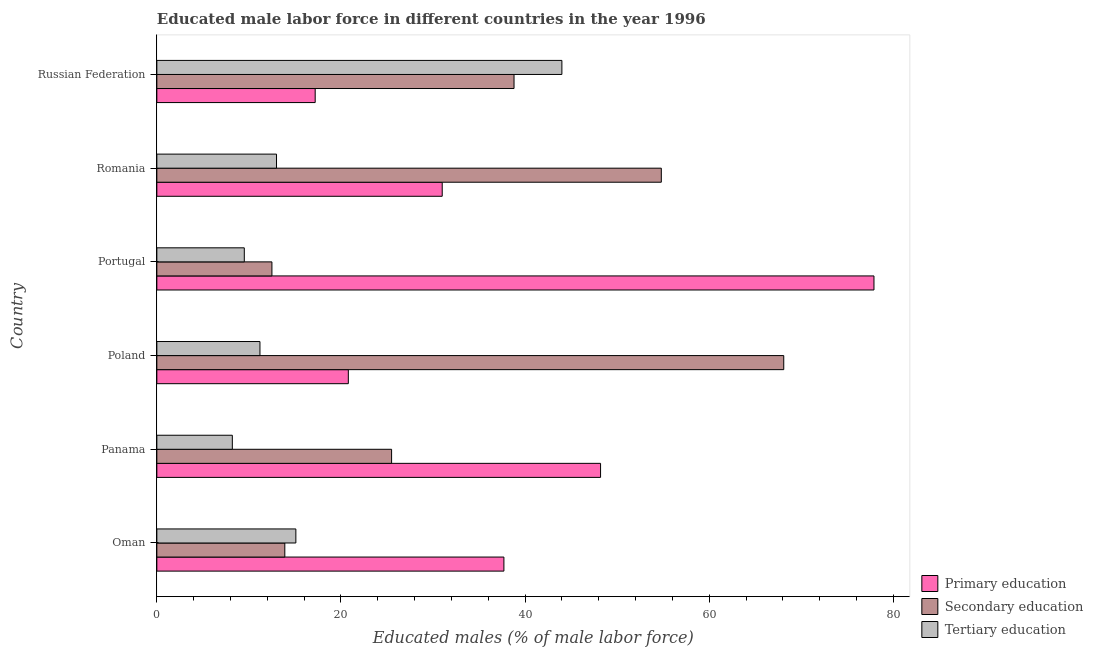Are the number of bars per tick equal to the number of legend labels?
Give a very brief answer. Yes. What is the label of the 6th group of bars from the top?
Your response must be concise. Oman. In how many cases, is the number of bars for a given country not equal to the number of legend labels?
Keep it short and to the point. 0. What is the percentage of male labor force who received tertiary education in Oman?
Offer a terse response. 15.1. Across all countries, what is the maximum percentage of male labor force who received tertiary education?
Ensure brevity in your answer.  44. In which country was the percentage of male labor force who received primary education minimum?
Ensure brevity in your answer.  Russian Federation. What is the total percentage of male labor force who received tertiary education in the graph?
Provide a succinct answer. 101. What is the difference between the percentage of male labor force who received secondary education in Poland and that in Russian Federation?
Make the answer very short. 29.3. What is the difference between the percentage of male labor force who received primary education in Panama and the percentage of male labor force who received tertiary education in Russian Federation?
Your answer should be compact. 4.2. What is the average percentage of male labor force who received tertiary education per country?
Your answer should be compact. 16.83. What is the ratio of the percentage of male labor force who received primary education in Oman to that in Russian Federation?
Make the answer very short. 2.19. Is the percentage of male labor force who received secondary education in Poland less than that in Russian Federation?
Keep it short and to the point. No. What is the difference between the highest and the second highest percentage of male labor force who received tertiary education?
Make the answer very short. 28.9. What is the difference between the highest and the lowest percentage of male labor force who received tertiary education?
Your response must be concise. 35.8. Is the sum of the percentage of male labor force who received secondary education in Oman and Poland greater than the maximum percentage of male labor force who received tertiary education across all countries?
Ensure brevity in your answer.  Yes. What does the 3rd bar from the top in Poland represents?
Give a very brief answer. Primary education. What does the 3rd bar from the bottom in Portugal represents?
Offer a very short reply. Tertiary education. Are all the bars in the graph horizontal?
Provide a short and direct response. Yes. How many countries are there in the graph?
Provide a short and direct response. 6. What is the difference between two consecutive major ticks on the X-axis?
Give a very brief answer. 20. Are the values on the major ticks of X-axis written in scientific E-notation?
Offer a very short reply. No. Does the graph contain grids?
Offer a terse response. No. How many legend labels are there?
Your response must be concise. 3. How are the legend labels stacked?
Give a very brief answer. Vertical. What is the title of the graph?
Provide a short and direct response. Educated male labor force in different countries in the year 1996. Does "Food" appear as one of the legend labels in the graph?
Your answer should be very brief. No. What is the label or title of the X-axis?
Offer a very short reply. Educated males (% of male labor force). What is the Educated males (% of male labor force) of Primary education in Oman?
Offer a terse response. 37.7. What is the Educated males (% of male labor force) of Secondary education in Oman?
Offer a terse response. 13.9. What is the Educated males (% of male labor force) of Tertiary education in Oman?
Your response must be concise. 15.1. What is the Educated males (% of male labor force) in Primary education in Panama?
Give a very brief answer. 48.2. What is the Educated males (% of male labor force) in Secondary education in Panama?
Ensure brevity in your answer.  25.5. What is the Educated males (% of male labor force) of Tertiary education in Panama?
Keep it short and to the point. 8.2. What is the Educated males (% of male labor force) of Primary education in Poland?
Your answer should be compact. 20.8. What is the Educated males (% of male labor force) of Secondary education in Poland?
Keep it short and to the point. 68.1. What is the Educated males (% of male labor force) of Tertiary education in Poland?
Your response must be concise. 11.2. What is the Educated males (% of male labor force) of Primary education in Portugal?
Keep it short and to the point. 77.9. What is the Educated males (% of male labor force) of Tertiary education in Portugal?
Give a very brief answer. 9.5. What is the Educated males (% of male labor force) in Secondary education in Romania?
Your answer should be compact. 54.8. What is the Educated males (% of male labor force) of Primary education in Russian Federation?
Provide a succinct answer. 17.2. What is the Educated males (% of male labor force) of Secondary education in Russian Federation?
Offer a very short reply. 38.8. What is the Educated males (% of male labor force) of Tertiary education in Russian Federation?
Give a very brief answer. 44. Across all countries, what is the maximum Educated males (% of male labor force) of Primary education?
Give a very brief answer. 77.9. Across all countries, what is the maximum Educated males (% of male labor force) of Secondary education?
Provide a succinct answer. 68.1. Across all countries, what is the minimum Educated males (% of male labor force) of Primary education?
Offer a terse response. 17.2. Across all countries, what is the minimum Educated males (% of male labor force) in Tertiary education?
Give a very brief answer. 8.2. What is the total Educated males (% of male labor force) of Primary education in the graph?
Offer a terse response. 232.8. What is the total Educated males (% of male labor force) of Secondary education in the graph?
Make the answer very short. 213.6. What is the total Educated males (% of male labor force) in Tertiary education in the graph?
Your answer should be compact. 101. What is the difference between the Educated males (% of male labor force) in Tertiary education in Oman and that in Panama?
Provide a short and direct response. 6.9. What is the difference between the Educated males (% of male labor force) in Secondary education in Oman and that in Poland?
Make the answer very short. -54.2. What is the difference between the Educated males (% of male labor force) in Primary education in Oman and that in Portugal?
Give a very brief answer. -40.2. What is the difference between the Educated males (% of male labor force) of Secondary education in Oman and that in Portugal?
Your answer should be very brief. 1.4. What is the difference between the Educated males (% of male labor force) of Secondary education in Oman and that in Romania?
Keep it short and to the point. -40.9. What is the difference between the Educated males (% of male labor force) in Primary education in Oman and that in Russian Federation?
Provide a succinct answer. 20.5. What is the difference between the Educated males (% of male labor force) of Secondary education in Oman and that in Russian Federation?
Your answer should be very brief. -24.9. What is the difference between the Educated males (% of male labor force) in Tertiary education in Oman and that in Russian Federation?
Your answer should be compact. -28.9. What is the difference between the Educated males (% of male labor force) of Primary education in Panama and that in Poland?
Offer a very short reply. 27.4. What is the difference between the Educated males (% of male labor force) in Secondary education in Panama and that in Poland?
Keep it short and to the point. -42.6. What is the difference between the Educated males (% of male labor force) in Primary education in Panama and that in Portugal?
Provide a short and direct response. -29.7. What is the difference between the Educated males (% of male labor force) of Primary education in Panama and that in Romania?
Ensure brevity in your answer.  17.2. What is the difference between the Educated males (% of male labor force) in Secondary education in Panama and that in Romania?
Your response must be concise. -29.3. What is the difference between the Educated males (% of male labor force) in Tertiary education in Panama and that in Romania?
Your response must be concise. -4.8. What is the difference between the Educated males (% of male labor force) in Secondary education in Panama and that in Russian Federation?
Your answer should be compact. -13.3. What is the difference between the Educated males (% of male labor force) in Tertiary education in Panama and that in Russian Federation?
Offer a terse response. -35.8. What is the difference between the Educated males (% of male labor force) in Primary education in Poland and that in Portugal?
Provide a short and direct response. -57.1. What is the difference between the Educated males (% of male labor force) in Secondary education in Poland and that in Portugal?
Offer a very short reply. 55.6. What is the difference between the Educated males (% of male labor force) of Secondary education in Poland and that in Romania?
Provide a short and direct response. 13.3. What is the difference between the Educated males (% of male labor force) in Tertiary education in Poland and that in Romania?
Provide a succinct answer. -1.8. What is the difference between the Educated males (% of male labor force) of Primary education in Poland and that in Russian Federation?
Keep it short and to the point. 3.6. What is the difference between the Educated males (% of male labor force) in Secondary education in Poland and that in Russian Federation?
Offer a terse response. 29.3. What is the difference between the Educated males (% of male labor force) of Tertiary education in Poland and that in Russian Federation?
Make the answer very short. -32.8. What is the difference between the Educated males (% of male labor force) in Primary education in Portugal and that in Romania?
Your answer should be compact. 46.9. What is the difference between the Educated males (% of male labor force) of Secondary education in Portugal and that in Romania?
Provide a succinct answer. -42.3. What is the difference between the Educated males (% of male labor force) of Tertiary education in Portugal and that in Romania?
Provide a succinct answer. -3.5. What is the difference between the Educated males (% of male labor force) of Primary education in Portugal and that in Russian Federation?
Give a very brief answer. 60.7. What is the difference between the Educated males (% of male labor force) in Secondary education in Portugal and that in Russian Federation?
Ensure brevity in your answer.  -26.3. What is the difference between the Educated males (% of male labor force) of Tertiary education in Portugal and that in Russian Federation?
Your answer should be very brief. -34.5. What is the difference between the Educated males (% of male labor force) in Primary education in Romania and that in Russian Federation?
Offer a terse response. 13.8. What is the difference between the Educated males (% of male labor force) in Tertiary education in Romania and that in Russian Federation?
Keep it short and to the point. -31. What is the difference between the Educated males (% of male labor force) in Primary education in Oman and the Educated males (% of male labor force) in Tertiary education in Panama?
Offer a very short reply. 29.5. What is the difference between the Educated males (% of male labor force) of Secondary education in Oman and the Educated males (% of male labor force) of Tertiary education in Panama?
Offer a terse response. 5.7. What is the difference between the Educated males (% of male labor force) in Primary education in Oman and the Educated males (% of male labor force) in Secondary education in Poland?
Ensure brevity in your answer.  -30.4. What is the difference between the Educated males (% of male labor force) in Secondary education in Oman and the Educated males (% of male labor force) in Tertiary education in Poland?
Provide a short and direct response. 2.7. What is the difference between the Educated males (% of male labor force) of Primary education in Oman and the Educated males (% of male labor force) of Secondary education in Portugal?
Ensure brevity in your answer.  25.2. What is the difference between the Educated males (% of male labor force) in Primary education in Oman and the Educated males (% of male labor force) in Tertiary education in Portugal?
Give a very brief answer. 28.2. What is the difference between the Educated males (% of male labor force) of Primary education in Oman and the Educated males (% of male labor force) of Secondary education in Romania?
Give a very brief answer. -17.1. What is the difference between the Educated males (% of male labor force) in Primary education in Oman and the Educated males (% of male labor force) in Tertiary education in Romania?
Your answer should be very brief. 24.7. What is the difference between the Educated males (% of male labor force) of Secondary education in Oman and the Educated males (% of male labor force) of Tertiary education in Romania?
Provide a succinct answer. 0.9. What is the difference between the Educated males (% of male labor force) of Primary education in Oman and the Educated males (% of male labor force) of Secondary education in Russian Federation?
Provide a succinct answer. -1.1. What is the difference between the Educated males (% of male labor force) in Primary education in Oman and the Educated males (% of male labor force) in Tertiary education in Russian Federation?
Make the answer very short. -6.3. What is the difference between the Educated males (% of male labor force) of Secondary education in Oman and the Educated males (% of male labor force) of Tertiary education in Russian Federation?
Ensure brevity in your answer.  -30.1. What is the difference between the Educated males (% of male labor force) in Primary education in Panama and the Educated males (% of male labor force) in Secondary education in Poland?
Your answer should be very brief. -19.9. What is the difference between the Educated males (% of male labor force) in Primary education in Panama and the Educated males (% of male labor force) in Tertiary education in Poland?
Give a very brief answer. 37. What is the difference between the Educated males (% of male labor force) of Secondary education in Panama and the Educated males (% of male labor force) of Tertiary education in Poland?
Provide a short and direct response. 14.3. What is the difference between the Educated males (% of male labor force) of Primary education in Panama and the Educated males (% of male labor force) of Secondary education in Portugal?
Give a very brief answer. 35.7. What is the difference between the Educated males (% of male labor force) of Primary education in Panama and the Educated males (% of male labor force) of Tertiary education in Portugal?
Your answer should be compact. 38.7. What is the difference between the Educated males (% of male labor force) in Secondary education in Panama and the Educated males (% of male labor force) in Tertiary education in Portugal?
Make the answer very short. 16. What is the difference between the Educated males (% of male labor force) in Primary education in Panama and the Educated males (% of male labor force) in Tertiary education in Romania?
Your answer should be very brief. 35.2. What is the difference between the Educated males (% of male labor force) of Secondary education in Panama and the Educated males (% of male labor force) of Tertiary education in Romania?
Offer a very short reply. 12.5. What is the difference between the Educated males (% of male labor force) in Primary education in Panama and the Educated males (% of male labor force) in Secondary education in Russian Federation?
Offer a terse response. 9.4. What is the difference between the Educated males (% of male labor force) of Primary education in Panama and the Educated males (% of male labor force) of Tertiary education in Russian Federation?
Give a very brief answer. 4.2. What is the difference between the Educated males (% of male labor force) in Secondary education in Panama and the Educated males (% of male labor force) in Tertiary education in Russian Federation?
Make the answer very short. -18.5. What is the difference between the Educated males (% of male labor force) in Secondary education in Poland and the Educated males (% of male labor force) in Tertiary education in Portugal?
Ensure brevity in your answer.  58.6. What is the difference between the Educated males (% of male labor force) in Primary education in Poland and the Educated males (% of male labor force) in Secondary education in Romania?
Offer a terse response. -34. What is the difference between the Educated males (% of male labor force) of Primary education in Poland and the Educated males (% of male labor force) of Tertiary education in Romania?
Provide a succinct answer. 7.8. What is the difference between the Educated males (% of male labor force) of Secondary education in Poland and the Educated males (% of male labor force) of Tertiary education in Romania?
Your answer should be compact. 55.1. What is the difference between the Educated males (% of male labor force) of Primary education in Poland and the Educated males (% of male labor force) of Tertiary education in Russian Federation?
Keep it short and to the point. -23.2. What is the difference between the Educated males (% of male labor force) in Secondary education in Poland and the Educated males (% of male labor force) in Tertiary education in Russian Federation?
Make the answer very short. 24.1. What is the difference between the Educated males (% of male labor force) of Primary education in Portugal and the Educated males (% of male labor force) of Secondary education in Romania?
Offer a terse response. 23.1. What is the difference between the Educated males (% of male labor force) of Primary education in Portugal and the Educated males (% of male labor force) of Tertiary education in Romania?
Your answer should be very brief. 64.9. What is the difference between the Educated males (% of male labor force) in Secondary education in Portugal and the Educated males (% of male labor force) in Tertiary education in Romania?
Your response must be concise. -0.5. What is the difference between the Educated males (% of male labor force) of Primary education in Portugal and the Educated males (% of male labor force) of Secondary education in Russian Federation?
Make the answer very short. 39.1. What is the difference between the Educated males (% of male labor force) of Primary education in Portugal and the Educated males (% of male labor force) of Tertiary education in Russian Federation?
Make the answer very short. 33.9. What is the difference between the Educated males (% of male labor force) of Secondary education in Portugal and the Educated males (% of male labor force) of Tertiary education in Russian Federation?
Your response must be concise. -31.5. What is the difference between the Educated males (% of male labor force) of Primary education in Romania and the Educated males (% of male labor force) of Secondary education in Russian Federation?
Provide a short and direct response. -7.8. What is the average Educated males (% of male labor force) in Primary education per country?
Make the answer very short. 38.8. What is the average Educated males (% of male labor force) in Secondary education per country?
Make the answer very short. 35.6. What is the average Educated males (% of male labor force) in Tertiary education per country?
Offer a very short reply. 16.83. What is the difference between the Educated males (% of male labor force) in Primary education and Educated males (% of male labor force) in Secondary education in Oman?
Your answer should be very brief. 23.8. What is the difference between the Educated males (% of male labor force) of Primary education and Educated males (% of male labor force) of Tertiary education in Oman?
Provide a short and direct response. 22.6. What is the difference between the Educated males (% of male labor force) in Secondary education and Educated males (% of male labor force) in Tertiary education in Oman?
Ensure brevity in your answer.  -1.2. What is the difference between the Educated males (% of male labor force) of Primary education and Educated males (% of male labor force) of Secondary education in Panama?
Offer a very short reply. 22.7. What is the difference between the Educated males (% of male labor force) in Primary education and Educated males (% of male labor force) in Secondary education in Poland?
Provide a succinct answer. -47.3. What is the difference between the Educated males (% of male labor force) of Primary education and Educated males (% of male labor force) of Tertiary education in Poland?
Offer a very short reply. 9.6. What is the difference between the Educated males (% of male labor force) of Secondary education and Educated males (% of male labor force) of Tertiary education in Poland?
Ensure brevity in your answer.  56.9. What is the difference between the Educated males (% of male labor force) in Primary education and Educated males (% of male labor force) in Secondary education in Portugal?
Provide a succinct answer. 65.4. What is the difference between the Educated males (% of male labor force) of Primary education and Educated males (% of male labor force) of Tertiary education in Portugal?
Your answer should be compact. 68.4. What is the difference between the Educated males (% of male labor force) of Primary education and Educated males (% of male labor force) of Secondary education in Romania?
Make the answer very short. -23.8. What is the difference between the Educated males (% of male labor force) of Secondary education and Educated males (% of male labor force) of Tertiary education in Romania?
Your answer should be compact. 41.8. What is the difference between the Educated males (% of male labor force) of Primary education and Educated males (% of male labor force) of Secondary education in Russian Federation?
Offer a very short reply. -21.6. What is the difference between the Educated males (% of male labor force) of Primary education and Educated males (% of male labor force) of Tertiary education in Russian Federation?
Offer a very short reply. -26.8. What is the difference between the Educated males (% of male labor force) in Secondary education and Educated males (% of male labor force) in Tertiary education in Russian Federation?
Provide a succinct answer. -5.2. What is the ratio of the Educated males (% of male labor force) of Primary education in Oman to that in Panama?
Offer a very short reply. 0.78. What is the ratio of the Educated males (% of male labor force) in Secondary education in Oman to that in Panama?
Provide a succinct answer. 0.55. What is the ratio of the Educated males (% of male labor force) of Tertiary education in Oman to that in Panama?
Your answer should be very brief. 1.84. What is the ratio of the Educated males (% of male labor force) of Primary education in Oman to that in Poland?
Provide a succinct answer. 1.81. What is the ratio of the Educated males (% of male labor force) in Secondary education in Oman to that in Poland?
Keep it short and to the point. 0.2. What is the ratio of the Educated males (% of male labor force) of Tertiary education in Oman to that in Poland?
Provide a short and direct response. 1.35. What is the ratio of the Educated males (% of male labor force) in Primary education in Oman to that in Portugal?
Provide a succinct answer. 0.48. What is the ratio of the Educated males (% of male labor force) of Secondary education in Oman to that in Portugal?
Keep it short and to the point. 1.11. What is the ratio of the Educated males (% of male labor force) in Tertiary education in Oman to that in Portugal?
Provide a short and direct response. 1.59. What is the ratio of the Educated males (% of male labor force) of Primary education in Oman to that in Romania?
Keep it short and to the point. 1.22. What is the ratio of the Educated males (% of male labor force) in Secondary education in Oman to that in Romania?
Your answer should be compact. 0.25. What is the ratio of the Educated males (% of male labor force) in Tertiary education in Oman to that in Romania?
Keep it short and to the point. 1.16. What is the ratio of the Educated males (% of male labor force) in Primary education in Oman to that in Russian Federation?
Offer a terse response. 2.19. What is the ratio of the Educated males (% of male labor force) of Secondary education in Oman to that in Russian Federation?
Provide a succinct answer. 0.36. What is the ratio of the Educated males (% of male labor force) of Tertiary education in Oman to that in Russian Federation?
Your answer should be very brief. 0.34. What is the ratio of the Educated males (% of male labor force) in Primary education in Panama to that in Poland?
Offer a terse response. 2.32. What is the ratio of the Educated males (% of male labor force) in Secondary education in Panama to that in Poland?
Your answer should be very brief. 0.37. What is the ratio of the Educated males (% of male labor force) in Tertiary education in Panama to that in Poland?
Your answer should be very brief. 0.73. What is the ratio of the Educated males (% of male labor force) of Primary education in Panama to that in Portugal?
Provide a succinct answer. 0.62. What is the ratio of the Educated males (% of male labor force) of Secondary education in Panama to that in Portugal?
Provide a succinct answer. 2.04. What is the ratio of the Educated males (% of male labor force) of Tertiary education in Panama to that in Portugal?
Provide a succinct answer. 0.86. What is the ratio of the Educated males (% of male labor force) in Primary education in Panama to that in Romania?
Ensure brevity in your answer.  1.55. What is the ratio of the Educated males (% of male labor force) in Secondary education in Panama to that in Romania?
Ensure brevity in your answer.  0.47. What is the ratio of the Educated males (% of male labor force) of Tertiary education in Panama to that in Romania?
Ensure brevity in your answer.  0.63. What is the ratio of the Educated males (% of male labor force) in Primary education in Panama to that in Russian Federation?
Your response must be concise. 2.8. What is the ratio of the Educated males (% of male labor force) in Secondary education in Panama to that in Russian Federation?
Offer a very short reply. 0.66. What is the ratio of the Educated males (% of male labor force) of Tertiary education in Panama to that in Russian Federation?
Offer a terse response. 0.19. What is the ratio of the Educated males (% of male labor force) in Primary education in Poland to that in Portugal?
Ensure brevity in your answer.  0.27. What is the ratio of the Educated males (% of male labor force) of Secondary education in Poland to that in Portugal?
Offer a very short reply. 5.45. What is the ratio of the Educated males (% of male labor force) of Tertiary education in Poland to that in Portugal?
Your answer should be compact. 1.18. What is the ratio of the Educated males (% of male labor force) of Primary education in Poland to that in Romania?
Give a very brief answer. 0.67. What is the ratio of the Educated males (% of male labor force) of Secondary education in Poland to that in Romania?
Give a very brief answer. 1.24. What is the ratio of the Educated males (% of male labor force) in Tertiary education in Poland to that in Romania?
Offer a very short reply. 0.86. What is the ratio of the Educated males (% of male labor force) of Primary education in Poland to that in Russian Federation?
Provide a succinct answer. 1.21. What is the ratio of the Educated males (% of male labor force) in Secondary education in Poland to that in Russian Federation?
Keep it short and to the point. 1.76. What is the ratio of the Educated males (% of male labor force) in Tertiary education in Poland to that in Russian Federation?
Your answer should be compact. 0.25. What is the ratio of the Educated males (% of male labor force) of Primary education in Portugal to that in Romania?
Ensure brevity in your answer.  2.51. What is the ratio of the Educated males (% of male labor force) of Secondary education in Portugal to that in Romania?
Offer a terse response. 0.23. What is the ratio of the Educated males (% of male labor force) in Tertiary education in Portugal to that in Romania?
Keep it short and to the point. 0.73. What is the ratio of the Educated males (% of male labor force) of Primary education in Portugal to that in Russian Federation?
Make the answer very short. 4.53. What is the ratio of the Educated males (% of male labor force) of Secondary education in Portugal to that in Russian Federation?
Your answer should be very brief. 0.32. What is the ratio of the Educated males (% of male labor force) in Tertiary education in Portugal to that in Russian Federation?
Your answer should be very brief. 0.22. What is the ratio of the Educated males (% of male labor force) of Primary education in Romania to that in Russian Federation?
Provide a succinct answer. 1.8. What is the ratio of the Educated males (% of male labor force) of Secondary education in Romania to that in Russian Federation?
Provide a succinct answer. 1.41. What is the ratio of the Educated males (% of male labor force) in Tertiary education in Romania to that in Russian Federation?
Provide a succinct answer. 0.3. What is the difference between the highest and the second highest Educated males (% of male labor force) of Primary education?
Ensure brevity in your answer.  29.7. What is the difference between the highest and the second highest Educated males (% of male labor force) of Tertiary education?
Provide a short and direct response. 28.9. What is the difference between the highest and the lowest Educated males (% of male labor force) in Primary education?
Your answer should be compact. 60.7. What is the difference between the highest and the lowest Educated males (% of male labor force) of Secondary education?
Ensure brevity in your answer.  55.6. What is the difference between the highest and the lowest Educated males (% of male labor force) of Tertiary education?
Provide a succinct answer. 35.8. 